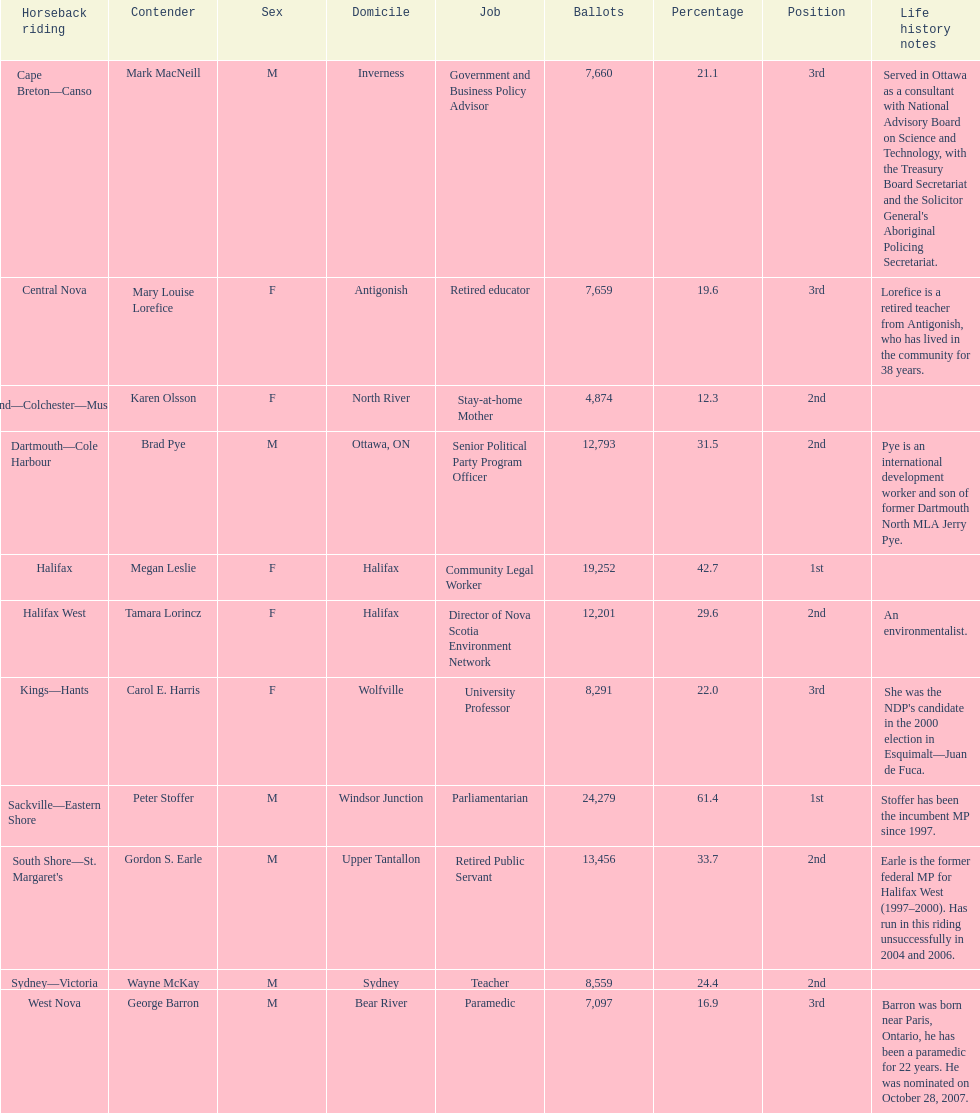Who received the highest number of votes? Sackville-Eastern Shore. 